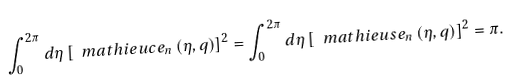<formula> <loc_0><loc_0><loc_500><loc_500>\int _ { 0 } ^ { 2 \pi } d \eta \left [ \ m a t h i e u c e _ { n } \left ( \eta , q \right ) \right ] ^ { 2 } = \int _ { 0 } ^ { 2 \pi } d \eta \left [ \ m a t h i e u s e _ { n } \left ( \eta , q \right ) \right ] ^ { 2 } = \pi .</formula> 